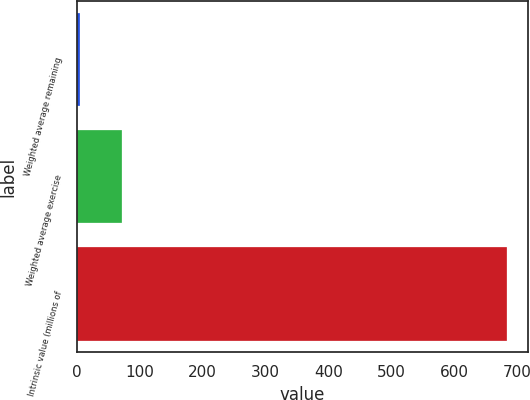Convert chart. <chart><loc_0><loc_0><loc_500><loc_500><bar_chart><fcel>Weighted average remaining<fcel>Weighted average exercise<fcel>Intrinsic value (millions of<nl><fcel>4.6<fcel>72.44<fcel>683<nl></chart> 